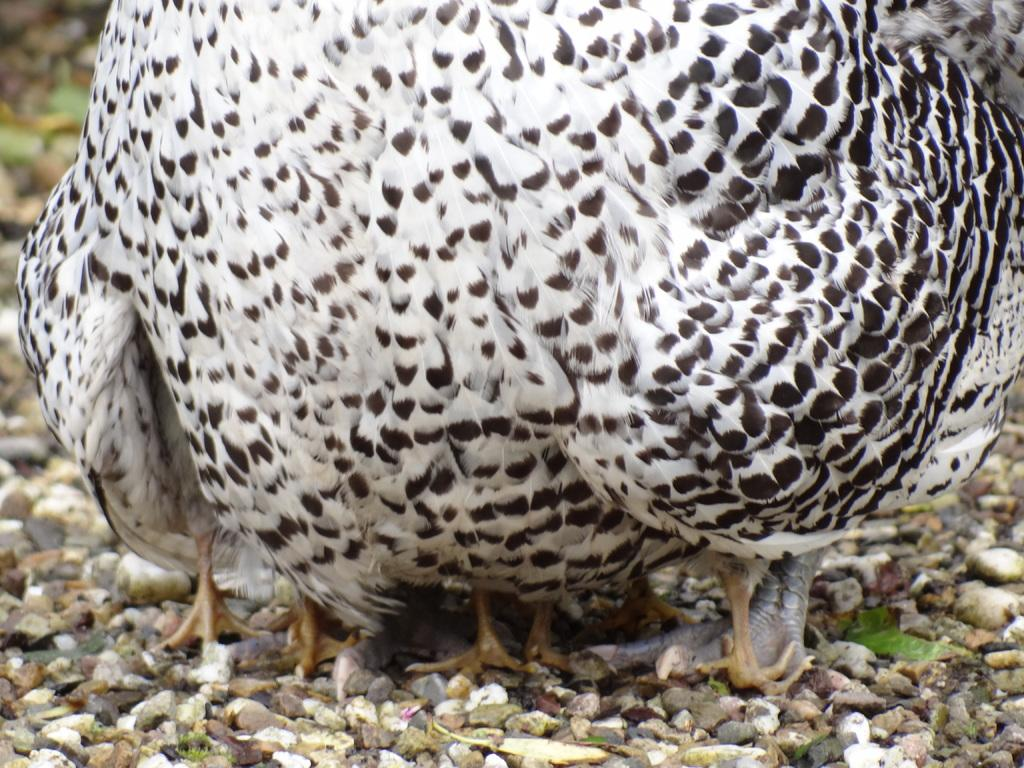What type of animals can be seen in the image? There are birds in the image. What can be seen on the ground in the image? There are stones on the ground in the image. What type of liquid is being poured from the net in the image? There is no liquid or net present in the image; it features birds and stones on the ground. 